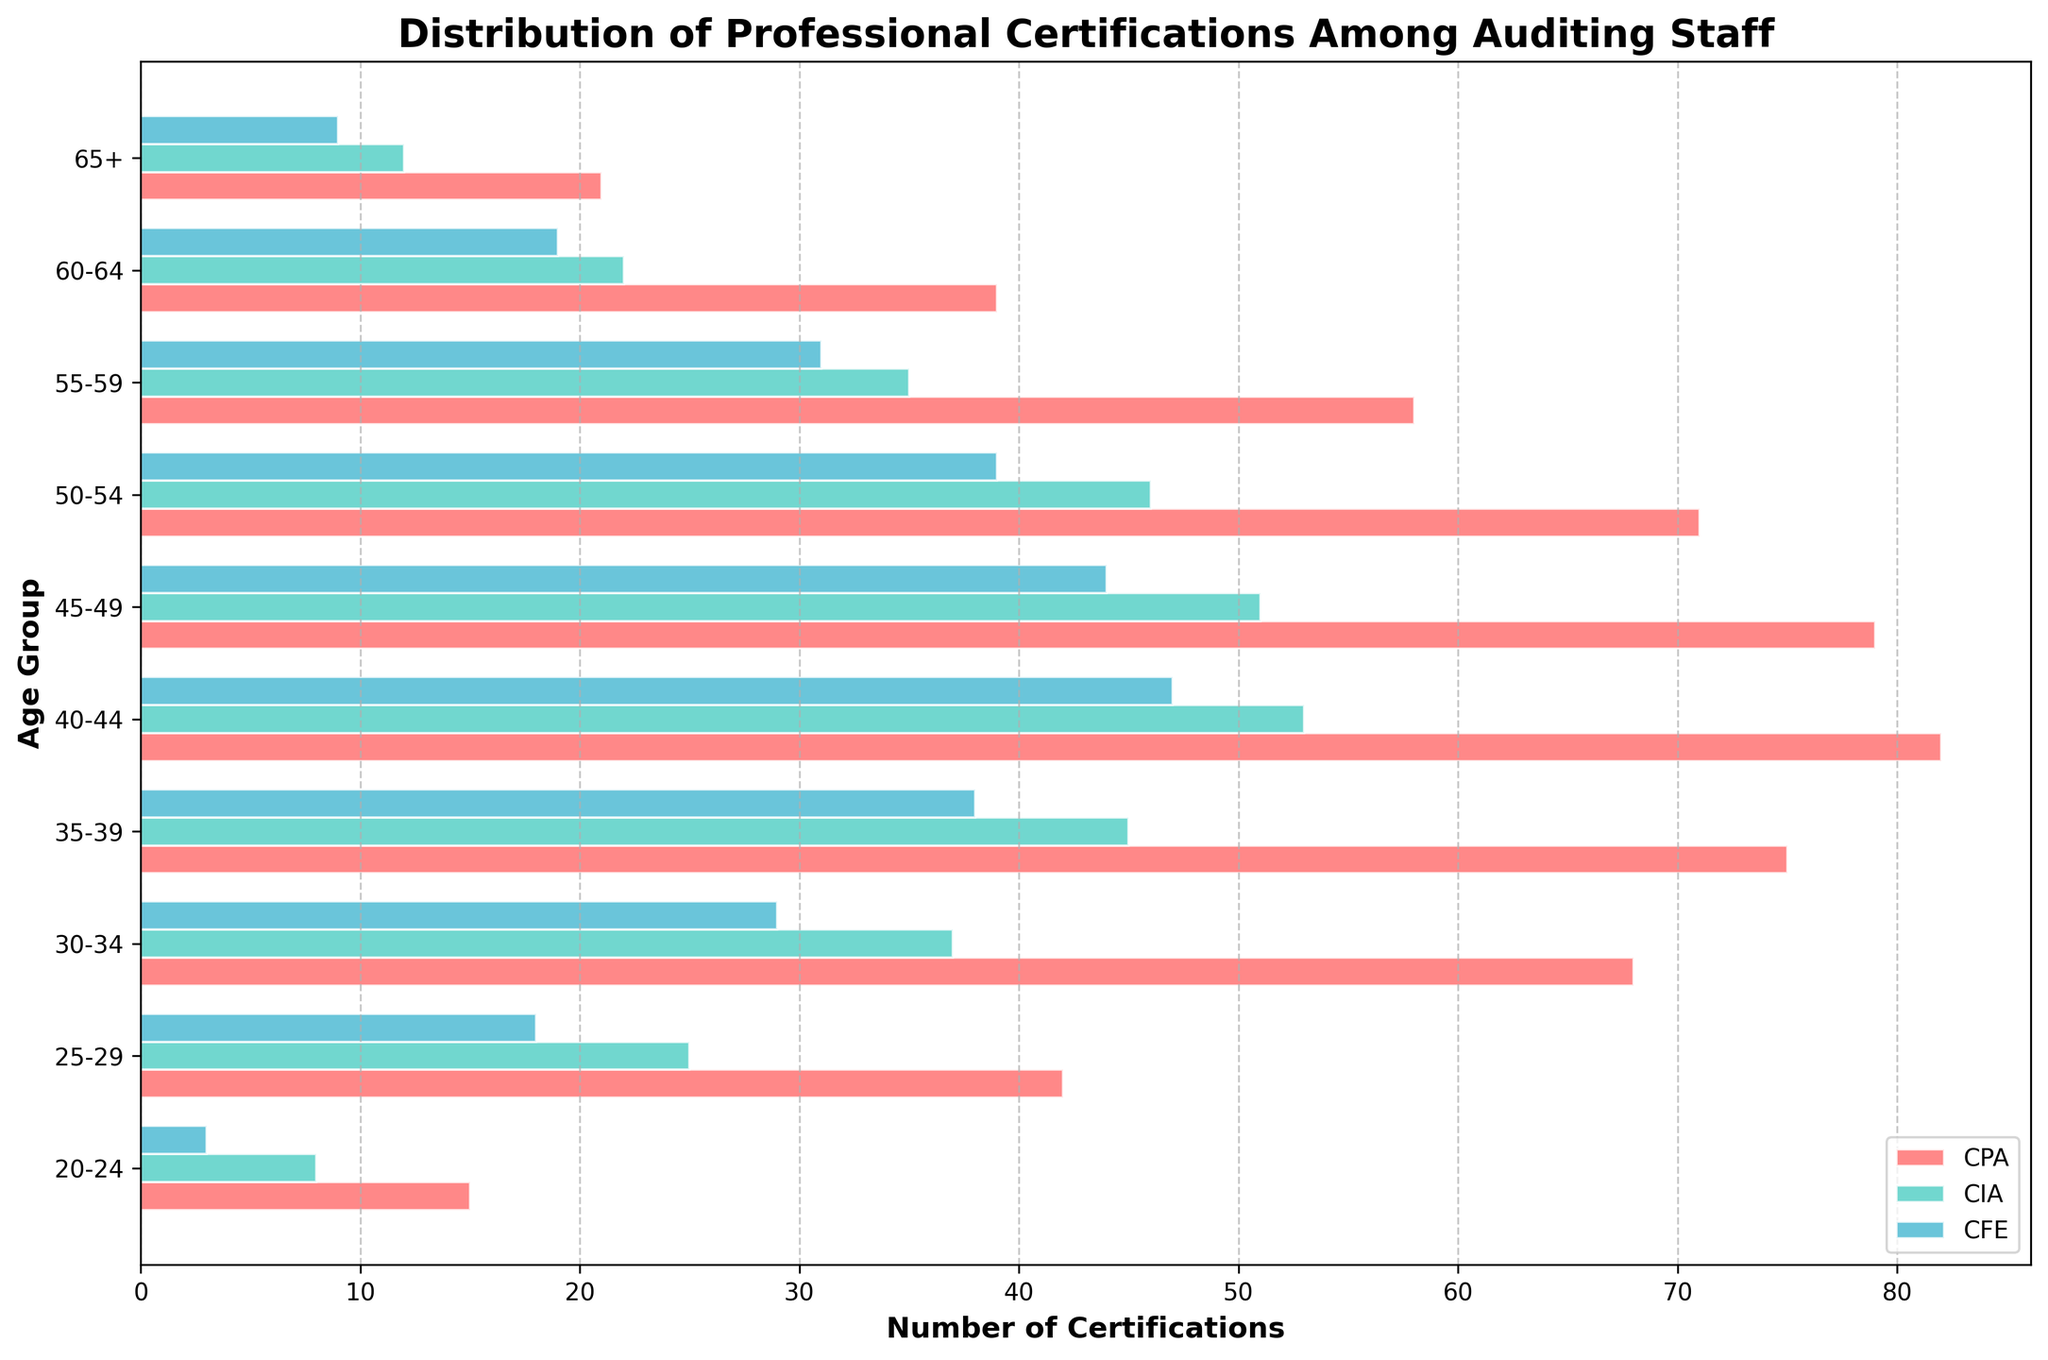How many age groups are represented in the figure? Count the number of unique age groups on the y-axis.
Answer: 10 What is the title of the figure? Look at the top of the figure where titles are typically placed.
Answer: Distribution of Professional Certifications Among Auditing Staff Which certification has the highest count in the 40-44 age group? Compare the three bars (CPA, CIA, CFE) for the 40-44 age group. The tallest bar represents the highest count.
Answer: CPA What's the sum of CPA certifications in the 25-29 and 30-34 age groups? Add the CPA counts for the 25-29 age group and the 30-34 age group. 42 + 68 = 110
Answer: 110 Which age group has the most CFE certifications? Look for the age group with the longest CFE bar.
Answer: 40-44 In which age group does CIA have the least number of certifications? Identify the shortest CIA bar among all the age groups.
Answer: 65+ Compare the number of CPA and CIA certifications in the 50-54 age group. Which one is higher? Compare the lengths of the CPA and CIA bars for the 50-54 age group.
Answer: CPA What is the difference between the number of CPA and CFE certifications in the 35-39 age group? Subtract the number of CFE certifications from the number of CPA certifications in the 35-39 age section. 75 - 38 = 37
Answer: 37 What's the total number of certifications (CPA, CIA, CFE) for the 55-59 age group? Sum the total certifications in the 55-59 age group: CPA (58) + CIA (35) + CFE (31). 58 + 35 + 31 = 124
Answer: 124 Which age group has more CPA certifications: 20-24 or 65+? Compare the CPA bars for the 20-24 and 65+ age groups. The longer bar indicates more certifications.
Answer: 20-24 